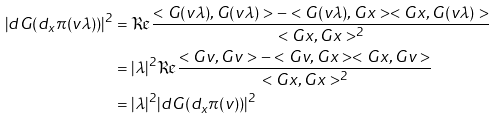Convert formula to latex. <formula><loc_0><loc_0><loc_500><loc_500>| d G ( d _ { x } \pi ( v \lambda ) ) | ^ { 2 } & = \Re \frac { < G ( v \lambda ) , G ( v \lambda ) > - < G ( v \lambda ) , G x > < G x , G ( v \lambda ) > } { < G x , G x > ^ { 2 } } \\ & = | \lambda | ^ { 2 } \Re \frac { < G v , G v > - < G v , G x > < G x , G v > } { < G x , G x > ^ { 2 } } \\ & = | \lambda | ^ { 2 } | d G ( d _ { x } \pi ( v ) ) | ^ { 2 }</formula> 